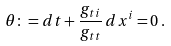<formula> <loc_0><loc_0><loc_500><loc_500>\theta \colon = d t + \frac { g _ { t i } } { g _ { t t } } \, d x ^ { i } = 0 \, .</formula> 